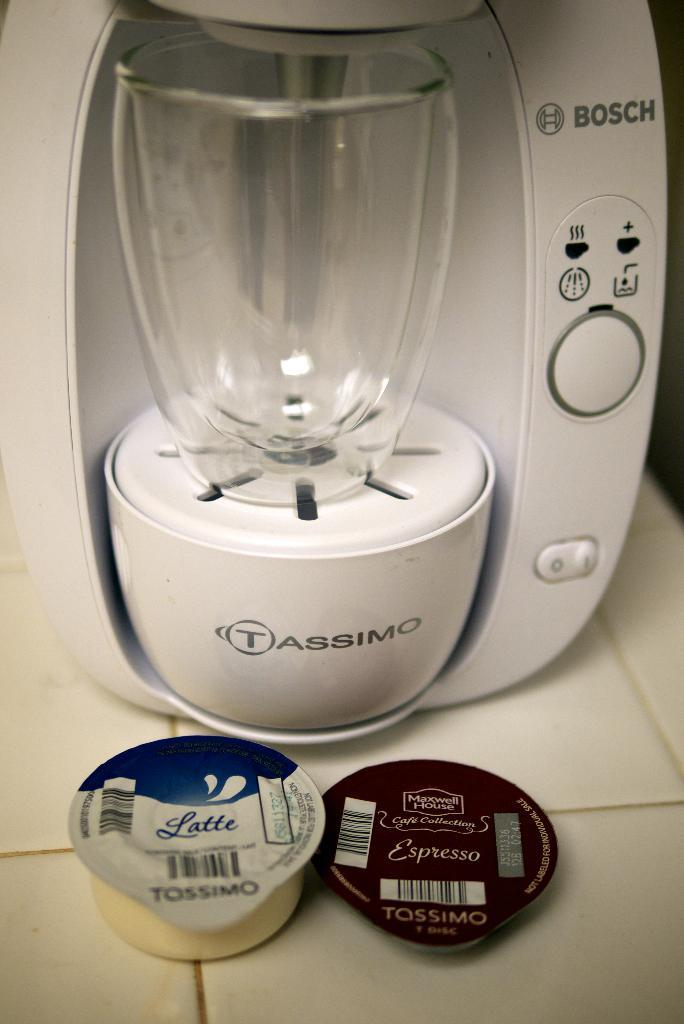<image>
Offer a succinct explanation of the picture presented. A Bosch Tassimo coffee maker and some Tossimo coffee pods. 